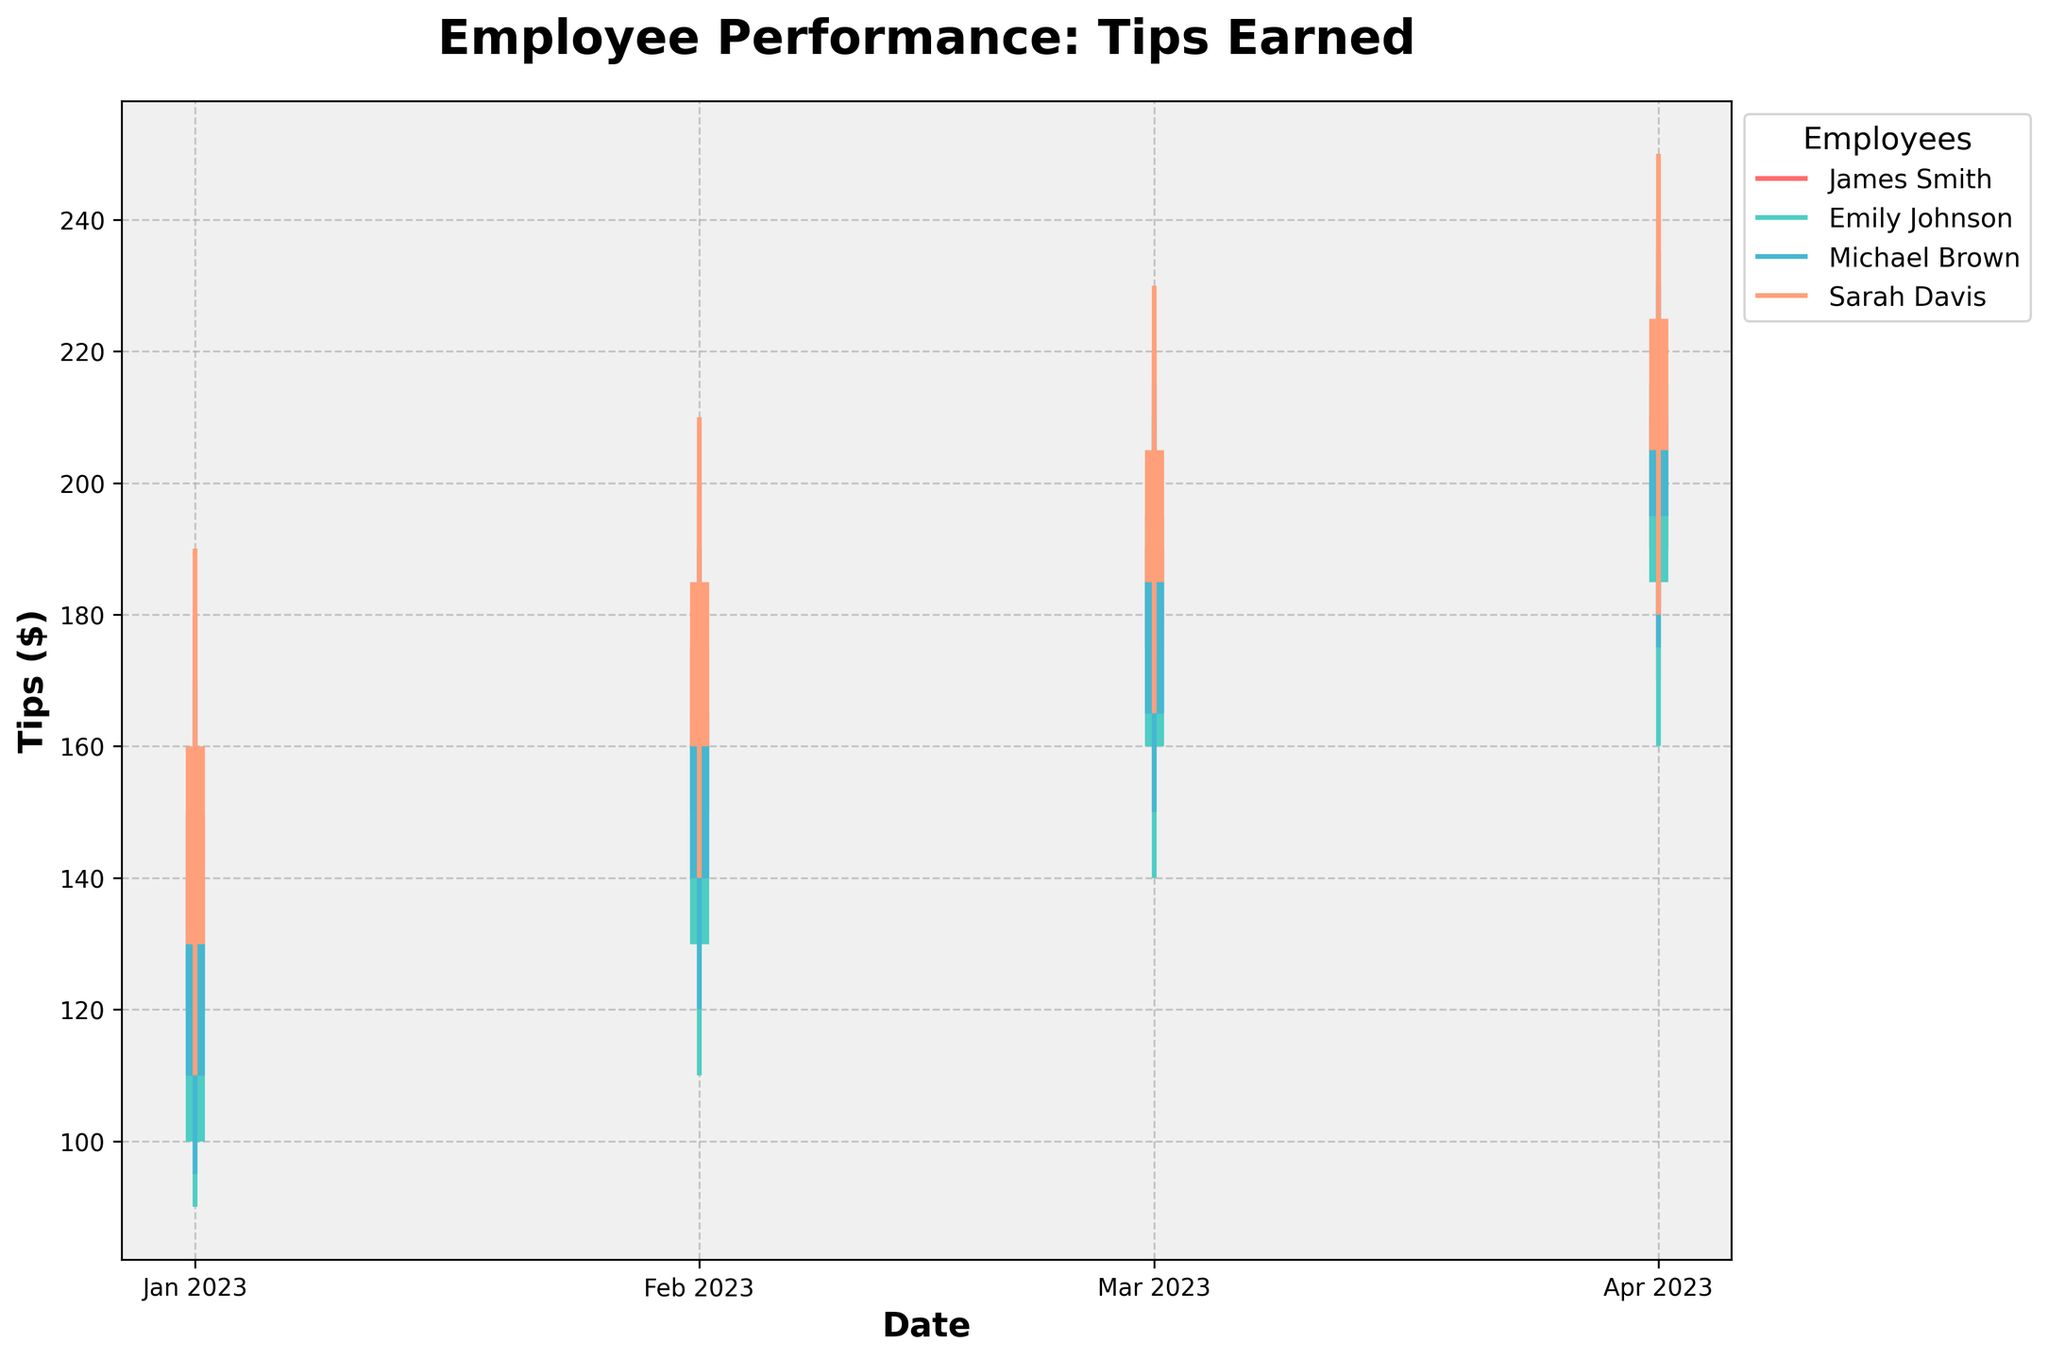Which employee showed the highest closing tips in April 2023? Look at the closing tips for each employee in April 2023. James Smith had 210, Emily Johnson had 200, Michael Brown had 215, and Sarah Davis had 225. Sarah Davis had the highest closing tips.
Answer: Sarah Davis What is the average customer rating for James Smith over the reported periods? James Smith's ratings over the reported periods are 4.7, 4.8, 4.9, and 4.8. Average customer rating is calculated as (4.7 + 4.8 + 4.9 + 4.8) / 4, which equals 4.8.
Answer: 4.8 Whose tips showed the most consistent growth from January to April 2023? For each employee, compare the trends in their opening and closing tips. James Smith moved from 120 to 150, ending at 190 to 210. Emily Johnson moved from 100 to 130, ending at 185 to 200. Michael Brown moved from 110 to 140, ending at 195 to 215. Sarah Davis moved from 130 to 160, ending at 205 to 225. Each employee demonstrated growth, but Emily Johnson and Michael Brown show consistent increment without fluctuations.
Answer: Emily Johnson or Michael Brown Which month had the highest average tips among all employees? Calculate the average tips for each month by summing the tips for all employees and dividing by the number of employees:
January: (150 + 130 + 140 + 160) / 4 = 145
February: (175 + 160 + 165 + 185) / 4 = 171.25
March: (190 + 185 + 195 + 205) / 4 = 193.75
April: (210 + 200 + 215 + 225) / 4 = 212.5 
April had the highest average tips.
Answer: April How does Sarah Davis's performance in terms of customer ratings compare with the others? Comparing Sarah Davis’s customer ratings (4.8, 4.9, 4.9, 5.0) to James Smith (4.7, 4.8, 4.9, 4.8), Emily Johnson (4.6, 4.7, 4.8, 4.9), and Michael Brown (4.5, 4.6, 4.7, 4.8), Sarah Davis consistently receives the highest ratings across all periods.
Answer: Sarah Davis What is the range of tips for Michael Brown in March 2023? Look at Michael Brown’s tips in March 2023, with a low of 150 and a high of 215. The range is 215 - 150 = 65.
Answer: 65 